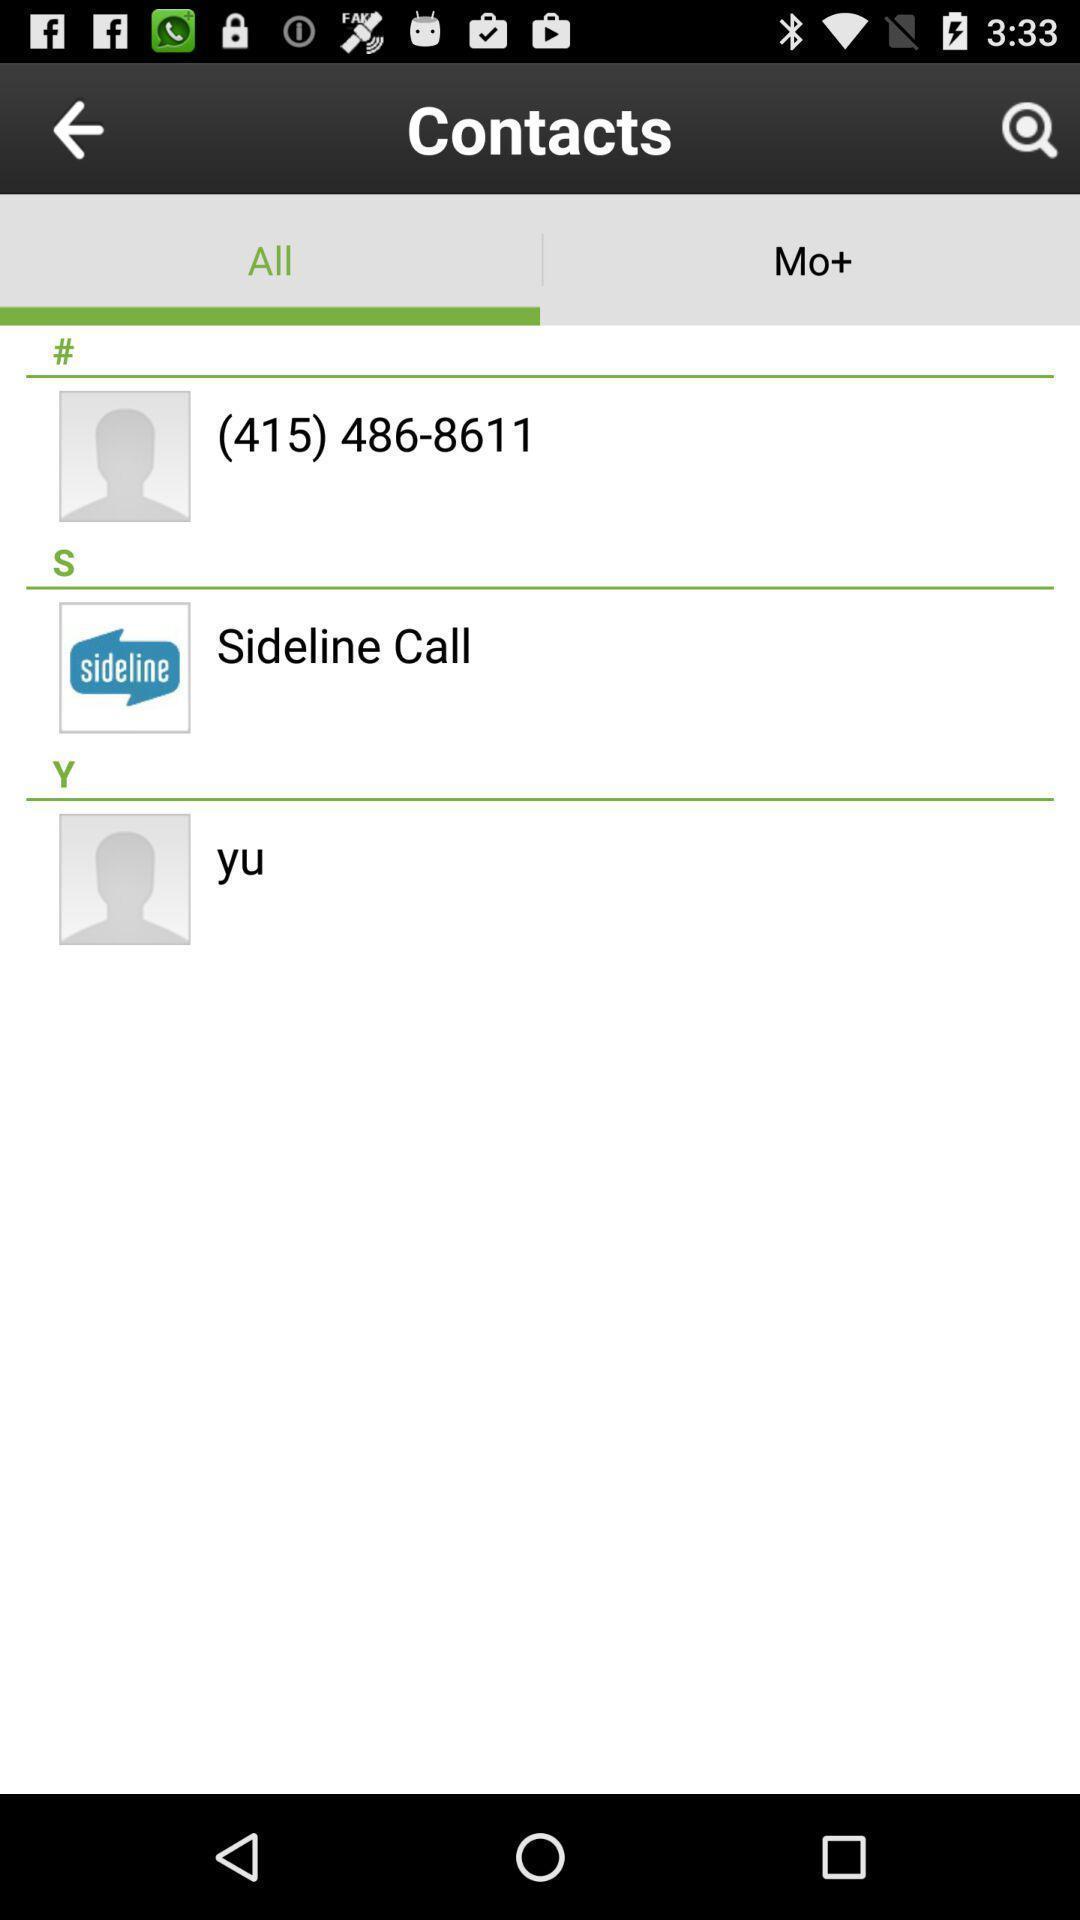Provide a detailed account of this screenshot. Page displaying with list of different contacts. 